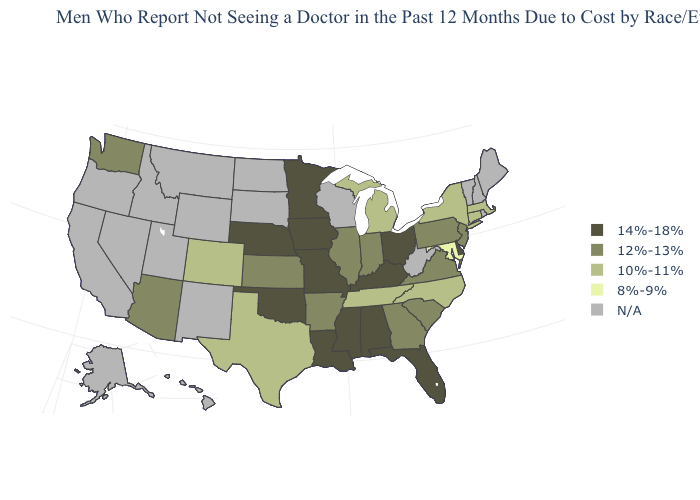Does Michigan have the lowest value in the MidWest?
Give a very brief answer. Yes. What is the lowest value in states that border Texas?
Be succinct. 12%-13%. Name the states that have a value in the range N/A?
Quick response, please. Alaska, California, Hawaii, Idaho, Maine, Montana, Nevada, New Hampshire, New Mexico, North Dakota, Oregon, Rhode Island, South Dakota, Utah, Vermont, West Virginia, Wisconsin, Wyoming. What is the highest value in the USA?
Write a very short answer. 14%-18%. What is the value of Delaware?
Quick response, please. 14%-18%. Does the first symbol in the legend represent the smallest category?
Keep it brief. No. What is the highest value in the MidWest ?
Write a very short answer. 14%-18%. What is the value of Arizona?
Concise answer only. 12%-13%. Does the map have missing data?
Quick response, please. Yes. What is the lowest value in the MidWest?
Give a very brief answer. 10%-11%. Among the states that border Wyoming , which have the lowest value?
Quick response, please. Colorado. Name the states that have a value in the range 10%-11%?
Be succinct. Colorado, Connecticut, Massachusetts, Michigan, New York, North Carolina, Tennessee, Texas. What is the lowest value in the Northeast?
Keep it brief. 10%-11%. Does the map have missing data?
Keep it brief. Yes. What is the value of West Virginia?
Concise answer only. N/A. 